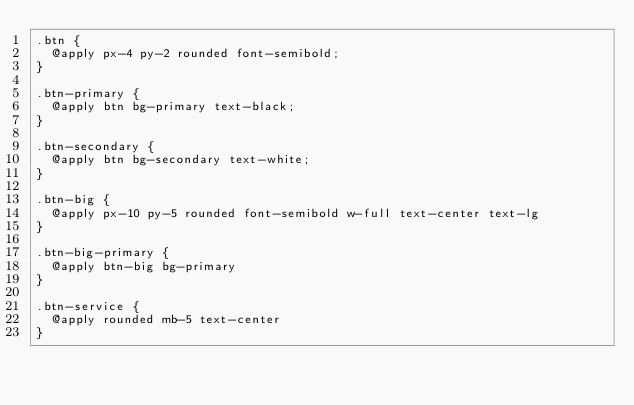<code> <loc_0><loc_0><loc_500><loc_500><_CSS_>.btn {
  @apply px-4 py-2 rounded font-semibold;
}

.btn-primary {
  @apply btn bg-primary text-black;
}

.btn-secondary {
  @apply btn bg-secondary text-white;
}

.btn-big {
  @apply px-10 py-5 rounded font-semibold w-full text-center text-lg
}

.btn-big-primary {
  @apply btn-big bg-primary
}

.btn-service {
  @apply rounded mb-5 text-center
}
</code> 